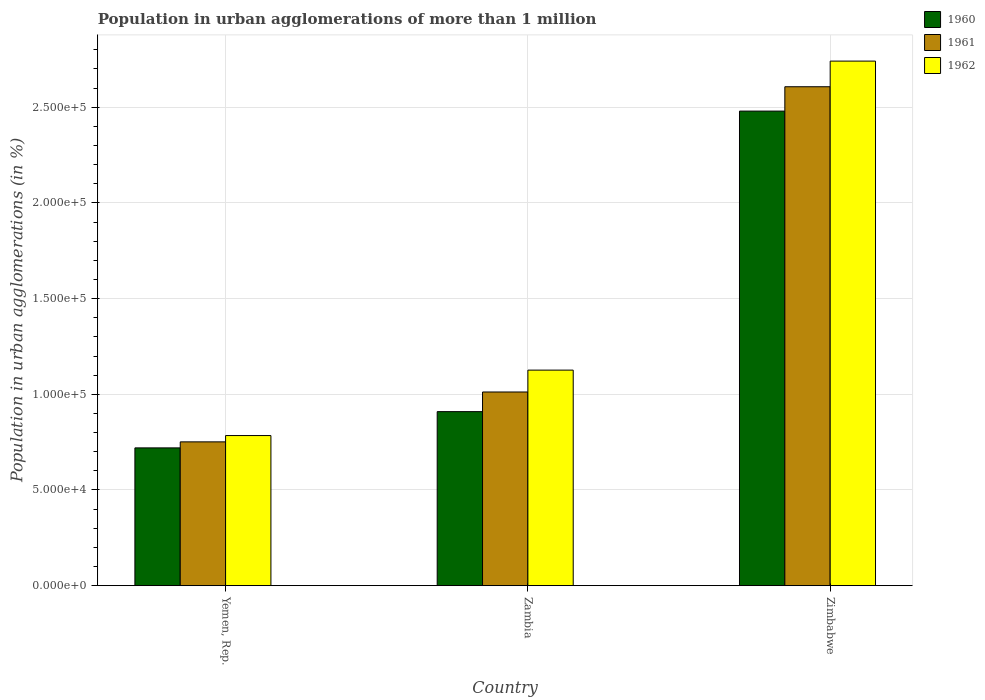How many different coloured bars are there?
Offer a very short reply. 3. How many groups of bars are there?
Keep it short and to the point. 3. How many bars are there on the 1st tick from the left?
Your answer should be compact. 3. How many bars are there on the 1st tick from the right?
Keep it short and to the point. 3. What is the label of the 2nd group of bars from the left?
Keep it short and to the point. Zambia. What is the population in urban agglomerations in 1962 in Yemen, Rep.?
Give a very brief answer. 7.84e+04. Across all countries, what is the maximum population in urban agglomerations in 1962?
Offer a very short reply. 2.74e+05. Across all countries, what is the minimum population in urban agglomerations in 1961?
Provide a succinct answer. 7.52e+04. In which country was the population in urban agglomerations in 1961 maximum?
Offer a terse response. Zimbabwe. In which country was the population in urban agglomerations in 1960 minimum?
Ensure brevity in your answer.  Yemen, Rep. What is the total population in urban agglomerations in 1962 in the graph?
Offer a terse response. 4.65e+05. What is the difference between the population in urban agglomerations in 1961 in Yemen, Rep. and that in Zambia?
Offer a very short reply. -2.61e+04. What is the difference between the population in urban agglomerations in 1960 in Yemen, Rep. and the population in urban agglomerations in 1961 in Zimbabwe?
Your response must be concise. -1.89e+05. What is the average population in urban agglomerations in 1962 per country?
Give a very brief answer. 1.55e+05. What is the difference between the population in urban agglomerations of/in 1962 and population in urban agglomerations of/in 1961 in Zambia?
Offer a terse response. 1.14e+04. In how many countries, is the population in urban agglomerations in 1961 greater than 220000 %?
Offer a terse response. 1. What is the ratio of the population in urban agglomerations in 1960 in Yemen, Rep. to that in Zambia?
Make the answer very short. 0.79. Is the population in urban agglomerations in 1962 in Yemen, Rep. less than that in Zambia?
Offer a very short reply. Yes. What is the difference between the highest and the second highest population in urban agglomerations in 1960?
Give a very brief answer. -1.76e+05. What is the difference between the highest and the lowest population in urban agglomerations in 1960?
Keep it short and to the point. 1.76e+05. Is the sum of the population in urban agglomerations in 1960 in Yemen, Rep. and Zimbabwe greater than the maximum population in urban agglomerations in 1962 across all countries?
Your response must be concise. Yes. What does the 3rd bar from the left in Zimbabwe represents?
Provide a short and direct response. 1962. What does the 3rd bar from the right in Zimbabwe represents?
Your answer should be very brief. 1960. Is it the case that in every country, the sum of the population in urban agglomerations in 1961 and population in urban agglomerations in 1962 is greater than the population in urban agglomerations in 1960?
Your answer should be compact. Yes. How many bars are there?
Make the answer very short. 9. Are all the bars in the graph horizontal?
Provide a succinct answer. No. What is the difference between two consecutive major ticks on the Y-axis?
Your response must be concise. 5.00e+04. Are the values on the major ticks of Y-axis written in scientific E-notation?
Give a very brief answer. Yes. How many legend labels are there?
Keep it short and to the point. 3. What is the title of the graph?
Your answer should be very brief. Population in urban agglomerations of more than 1 million. What is the label or title of the X-axis?
Your answer should be very brief. Country. What is the label or title of the Y-axis?
Keep it short and to the point. Population in urban agglomerations (in %). What is the Population in urban agglomerations (in %) of 1960 in Yemen, Rep.?
Ensure brevity in your answer.  7.20e+04. What is the Population in urban agglomerations (in %) in 1961 in Yemen, Rep.?
Your answer should be very brief. 7.52e+04. What is the Population in urban agglomerations (in %) of 1962 in Yemen, Rep.?
Offer a very short reply. 7.84e+04. What is the Population in urban agglomerations (in %) in 1960 in Zambia?
Offer a very short reply. 9.09e+04. What is the Population in urban agglomerations (in %) in 1961 in Zambia?
Offer a very short reply. 1.01e+05. What is the Population in urban agglomerations (in %) of 1962 in Zambia?
Ensure brevity in your answer.  1.13e+05. What is the Population in urban agglomerations (in %) of 1960 in Zimbabwe?
Your answer should be very brief. 2.48e+05. What is the Population in urban agglomerations (in %) in 1961 in Zimbabwe?
Offer a terse response. 2.61e+05. What is the Population in urban agglomerations (in %) in 1962 in Zimbabwe?
Provide a succinct answer. 2.74e+05. Across all countries, what is the maximum Population in urban agglomerations (in %) of 1960?
Make the answer very short. 2.48e+05. Across all countries, what is the maximum Population in urban agglomerations (in %) in 1961?
Give a very brief answer. 2.61e+05. Across all countries, what is the maximum Population in urban agglomerations (in %) of 1962?
Your answer should be compact. 2.74e+05. Across all countries, what is the minimum Population in urban agglomerations (in %) of 1960?
Your answer should be very brief. 7.20e+04. Across all countries, what is the minimum Population in urban agglomerations (in %) of 1961?
Offer a terse response. 7.52e+04. Across all countries, what is the minimum Population in urban agglomerations (in %) of 1962?
Offer a terse response. 7.84e+04. What is the total Population in urban agglomerations (in %) of 1960 in the graph?
Give a very brief answer. 4.11e+05. What is the total Population in urban agglomerations (in %) in 1961 in the graph?
Provide a short and direct response. 4.37e+05. What is the total Population in urban agglomerations (in %) in 1962 in the graph?
Provide a succinct answer. 4.65e+05. What is the difference between the Population in urban agglomerations (in %) of 1960 in Yemen, Rep. and that in Zambia?
Your answer should be compact. -1.89e+04. What is the difference between the Population in urban agglomerations (in %) of 1961 in Yemen, Rep. and that in Zambia?
Your response must be concise. -2.61e+04. What is the difference between the Population in urban agglomerations (in %) of 1962 in Yemen, Rep. and that in Zambia?
Your response must be concise. -3.42e+04. What is the difference between the Population in urban agglomerations (in %) of 1960 in Yemen, Rep. and that in Zimbabwe?
Provide a short and direct response. -1.76e+05. What is the difference between the Population in urban agglomerations (in %) of 1961 in Yemen, Rep. and that in Zimbabwe?
Offer a very short reply. -1.86e+05. What is the difference between the Population in urban agglomerations (in %) in 1962 in Yemen, Rep. and that in Zimbabwe?
Provide a succinct answer. -1.96e+05. What is the difference between the Population in urban agglomerations (in %) of 1960 in Zambia and that in Zimbabwe?
Provide a succinct answer. -1.57e+05. What is the difference between the Population in urban agglomerations (in %) of 1961 in Zambia and that in Zimbabwe?
Keep it short and to the point. -1.60e+05. What is the difference between the Population in urban agglomerations (in %) in 1962 in Zambia and that in Zimbabwe?
Your answer should be compact. -1.61e+05. What is the difference between the Population in urban agglomerations (in %) in 1960 in Yemen, Rep. and the Population in urban agglomerations (in %) in 1961 in Zambia?
Make the answer very short. -2.92e+04. What is the difference between the Population in urban agglomerations (in %) in 1960 in Yemen, Rep. and the Population in urban agglomerations (in %) in 1962 in Zambia?
Provide a succinct answer. -4.06e+04. What is the difference between the Population in urban agglomerations (in %) of 1961 in Yemen, Rep. and the Population in urban agglomerations (in %) of 1962 in Zambia?
Offer a terse response. -3.75e+04. What is the difference between the Population in urban agglomerations (in %) in 1960 in Yemen, Rep. and the Population in urban agglomerations (in %) in 1961 in Zimbabwe?
Offer a very short reply. -1.89e+05. What is the difference between the Population in urban agglomerations (in %) in 1960 in Yemen, Rep. and the Population in urban agglomerations (in %) in 1962 in Zimbabwe?
Provide a short and direct response. -2.02e+05. What is the difference between the Population in urban agglomerations (in %) in 1961 in Yemen, Rep. and the Population in urban agglomerations (in %) in 1962 in Zimbabwe?
Your response must be concise. -1.99e+05. What is the difference between the Population in urban agglomerations (in %) of 1960 in Zambia and the Population in urban agglomerations (in %) of 1961 in Zimbabwe?
Keep it short and to the point. -1.70e+05. What is the difference between the Population in urban agglomerations (in %) in 1960 in Zambia and the Population in urban agglomerations (in %) in 1962 in Zimbabwe?
Provide a succinct answer. -1.83e+05. What is the difference between the Population in urban agglomerations (in %) of 1961 in Zambia and the Population in urban agglomerations (in %) of 1962 in Zimbabwe?
Provide a succinct answer. -1.73e+05. What is the average Population in urban agglomerations (in %) in 1960 per country?
Keep it short and to the point. 1.37e+05. What is the average Population in urban agglomerations (in %) of 1961 per country?
Provide a short and direct response. 1.46e+05. What is the average Population in urban agglomerations (in %) of 1962 per country?
Keep it short and to the point. 1.55e+05. What is the difference between the Population in urban agglomerations (in %) in 1960 and Population in urban agglomerations (in %) in 1961 in Yemen, Rep.?
Your response must be concise. -3151. What is the difference between the Population in urban agglomerations (in %) of 1960 and Population in urban agglomerations (in %) of 1962 in Yemen, Rep.?
Make the answer very short. -6444. What is the difference between the Population in urban agglomerations (in %) in 1961 and Population in urban agglomerations (in %) in 1962 in Yemen, Rep.?
Make the answer very short. -3293. What is the difference between the Population in urban agglomerations (in %) of 1960 and Population in urban agglomerations (in %) of 1961 in Zambia?
Your answer should be very brief. -1.03e+04. What is the difference between the Population in urban agglomerations (in %) of 1960 and Population in urban agglomerations (in %) of 1962 in Zambia?
Offer a very short reply. -2.17e+04. What is the difference between the Population in urban agglomerations (in %) of 1961 and Population in urban agglomerations (in %) of 1962 in Zambia?
Your response must be concise. -1.14e+04. What is the difference between the Population in urban agglomerations (in %) in 1960 and Population in urban agglomerations (in %) in 1961 in Zimbabwe?
Your answer should be compact. -1.27e+04. What is the difference between the Population in urban agglomerations (in %) of 1960 and Population in urban agglomerations (in %) of 1962 in Zimbabwe?
Give a very brief answer. -2.61e+04. What is the difference between the Population in urban agglomerations (in %) in 1961 and Population in urban agglomerations (in %) in 1962 in Zimbabwe?
Your answer should be very brief. -1.34e+04. What is the ratio of the Population in urban agglomerations (in %) of 1960 in Yemen, Rep. to that in Zambia?
Offer a very short reply. 0.79. What is the ratio of the Population in urban agglomerations (in %) of 1961 in Yemen, Rep. to that in Zambia?
Offer a very short reply. 0.74. What is the ratio of the Population in urban agglomerations (in %) in 1962 in Yemen, Rep. to that in Zambia?
Make the answer very short. 0.7. What is the ratio of the Population in urban agglomerations (in %) in 1960 in Yemen, Rep. to that in Zimbabwe?
Make the answer very short. 0.29. What is the ratio of the Population in urban agglomerations (in %) in 1961 in Yemen, Rep. to that in Zimbabwe?
Ensure brevity in your answer.  0.29. What is the ratio of the Population in urban agglomerations (in %) in 1962 in Yemen, Rep. to that in Zimbabwe?
Keep it short and to the point. 0.29. What is the ratio of the Population in urban agglomerations (in %) in 1960 in Zambia to that in Zimbabwe?
Provide a short and direct response. 0.37. What is the ratio of the Population in urban agglomerations (in %) of 1961 in Zambia to that in Zimbabwe?
Make the answer very short. 0.39. What is the ratio of the Population in urban agglomerations (in %) in 1962 in Zambia to that in Zimbabwe?
Offer a terse response. 0.41. What is the difference between the highest and the second highest Population in urban agglomerations (in %) of 1960?
Ensure brevity in your answer.  1.57e+05. What is the difference between the highest and the second highest Population in urban agglomerations (in %) in 1961?
Offer a very short reply. 1.60e+05. What is the difference between the highest and the second highest Population in urban agglomerations (in %) of 1962?
Your answer should be very brief. 1.61e+05. What is the difference between the highest and the lowest Population in urban agglomerations (in %) in 1960?
Ensure brevity in your answer.  1.76e+05. What is the difference between the highest and the lowest Population in urban agglomerations (in %) in 1961?
Ensure brevity in your answer.  1.86e+05. What is the difference between the highest and the lowest Population in urban agglomerations (in %) in 1962?
Your answer should be very brief. 1.96e+05. 